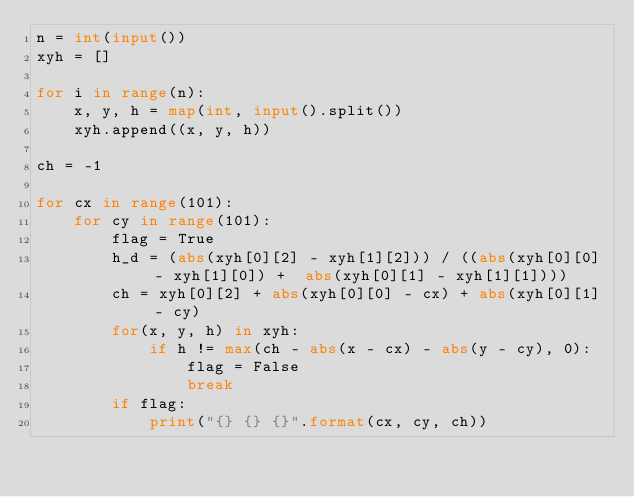Convert code to text. <code><loc_0><loc_0><loc_500><loc_500><_Python_>n = int(input())
xyh = []

for i in range(n):
    x, y, h = map(int, input().split())
    xyh.append((x, y, h))

ch = -1

for cx in range(101):
    for cy in range(101):
        flag = True
        h_d = (abs(xyh[0][2] - xyh[1][2])) / ((abs(xyh[0][0] - xyh[1][0]) +  abs(xyh[0][1] - xyh[1][1])))
        ch = xyh[0][2] + abs(xyh[0][0] - cx) + abs(xyh[0][1] - cy)
        for(x, y, h) in xyh:
            if h != max(ch - abs(x - cx) - abs(y - cy), 0):
                flag = False
                break
        if flag:
            print("{} {} {}".format(cx, cy, ch))</code> 